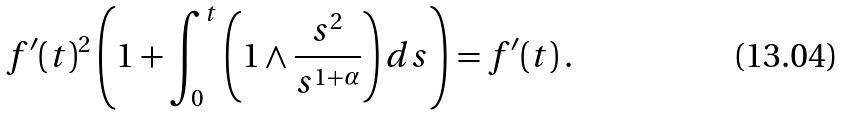Convert formula to latex. <formula><loc_0><loc_0><loc_500><loc_500>f ^ { \prime } ( t ) ^ { 2 } \left ( 1 + \int _ { 0 } ^ { t } \left ( 1 \wedge \frac { s ^ { 2 } } { s ^ { 1 + \alpha } } \right ) d s \right ) = f ^ { \prime } ( t ) \, .</formula> 